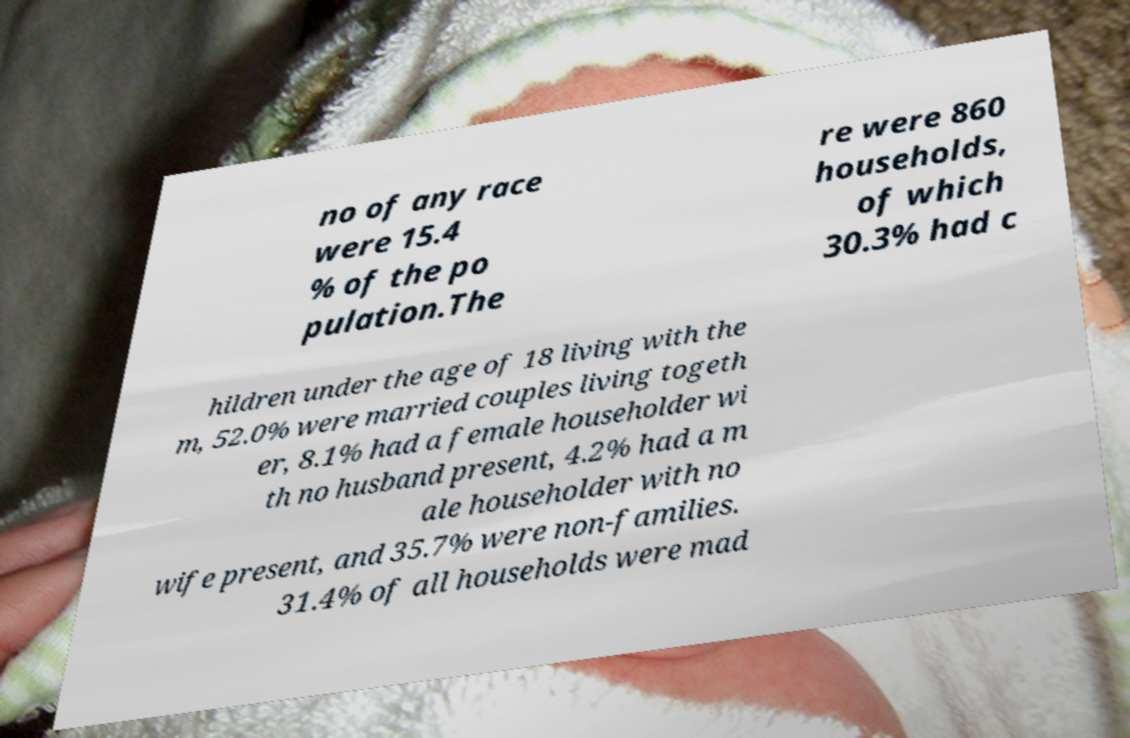Please identify and transcribe the text found in this image. no of any race were 15.4 % of the po pulation.The re were 860 households, of which 30.3% had c hildren under the age of 18 living with the m, 52.0% were married couples living togeth er, 8.1% had a female householder wi th no husband present, 4.2% had a m ale householder with no wife present, and 35.7% were non-families. 31.4% of all households were mad 